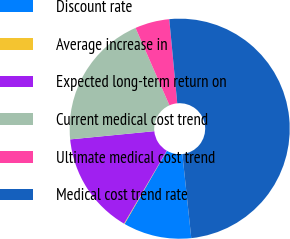Convert chart. <chart><loc_0><loc_0><loc_500><loc_500><pie_chart><fcel>Discount rate<fcel>Average increase in<fcel>Expected long-term return on<fcel>Current medical cost trend<fcel>Ultimate medical cost trend<fcel>Medical cost trend rate<nl><fcel>10.03%<fcel>0.09%<fcel>15.01%<fcel>19.98%<fcel>5.06%<fcel>49.83%<nl></chart> 